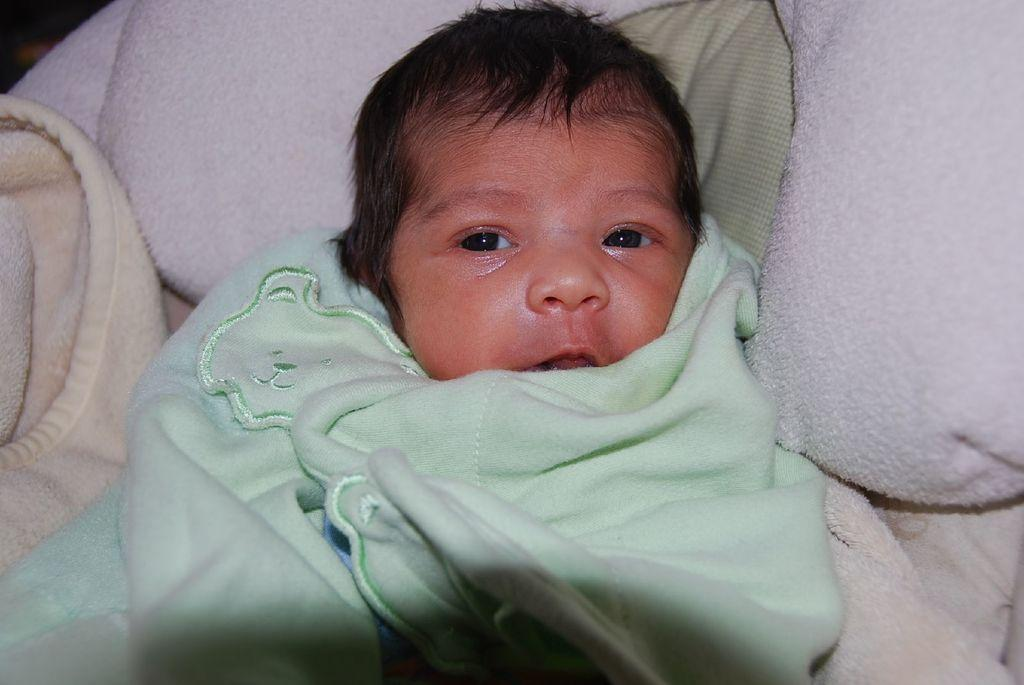What is the main subject of the image? The main subject of the image is a baby. What is the baby lying on in the image? The baby is lying on a blanket. What type of yoke is the baby holding in the image? There is no yoke present in the image; the baby is lying on a blanket. Can you see the baby playing basketball in the image? There is no basketball present in the image; the baby is lying on a blanket. 